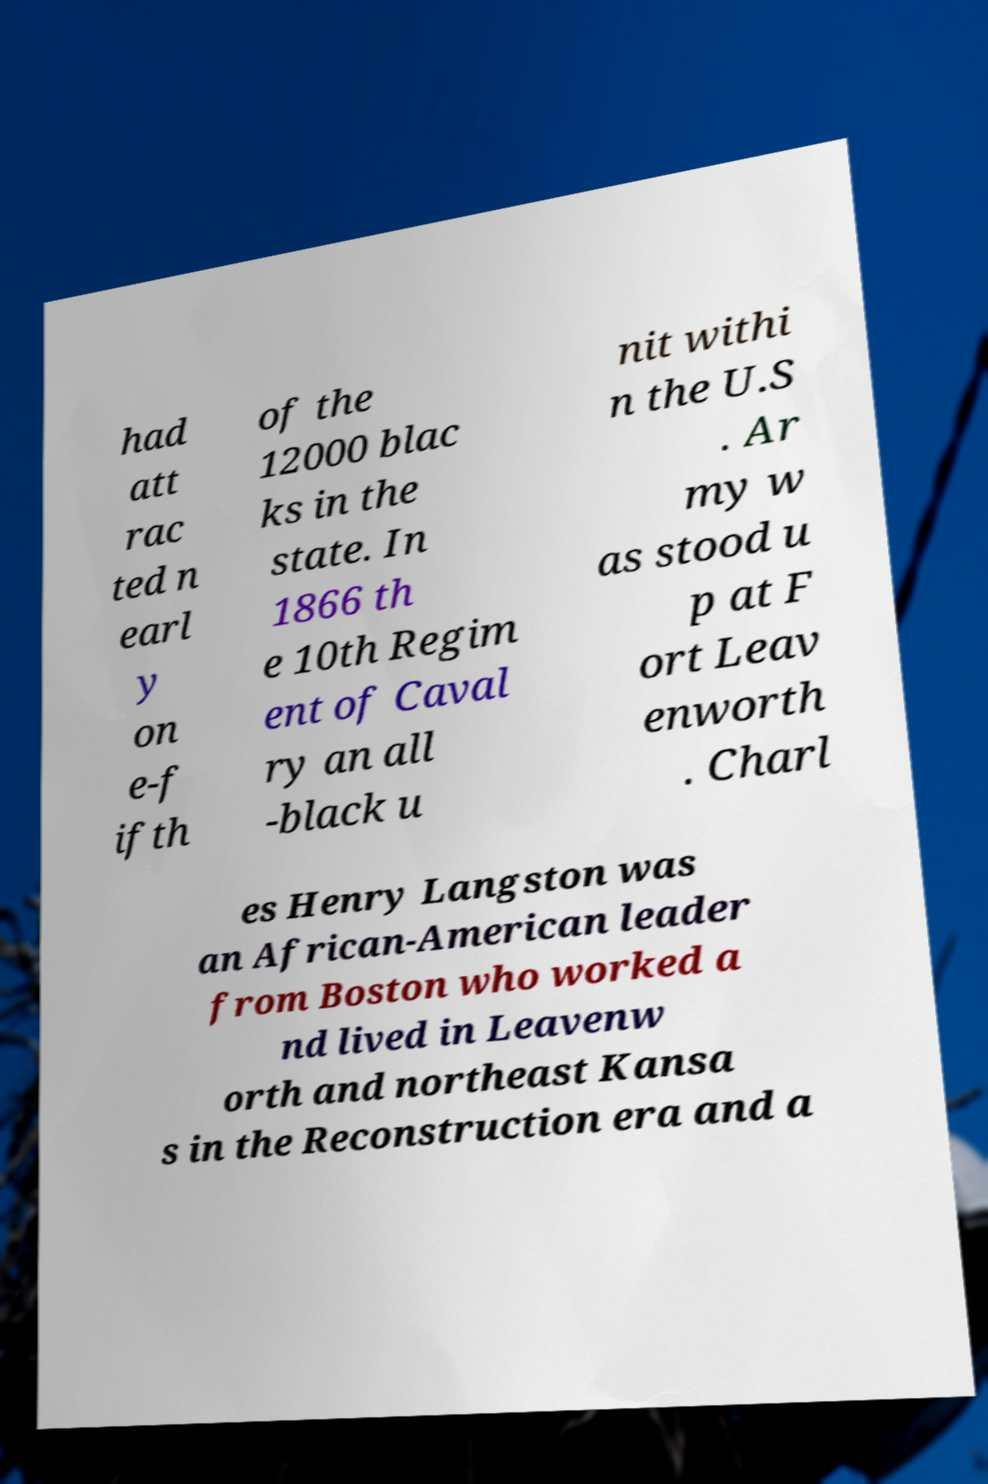Please read and relay the text visible in this image. What does it say? had att rac ted n earl y on e-f ifth of the 12000 blac ks in the state. In 1866 th e 10th Regim ent of Caval ry an all -black u nit withi n the U.S . Ar my w as stood u p at F ort Leav enworth . Charl es Henry Langston was an African-American leader from Boston who worked a nd lived in Leavenw orth and northeast Kansa s in the Reconstruction era and a 